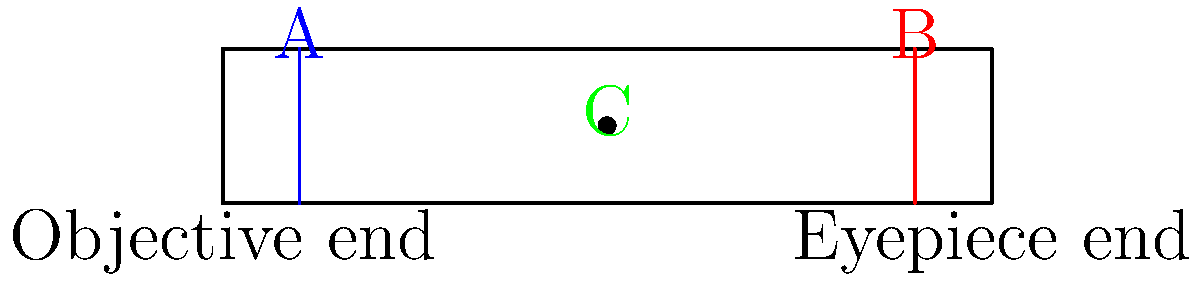In the schematic diagram of a refracting telescope above, what do the components labeled A, B, and C represent, and how do they contribute to the telescope's function in gathering data on distant celestial objects, which could be relevant to tracking the spread of infectious diseases from space-based observations? Step 1: Identify component A
A (blue line) represents the objective lens. It is the primary light-gathering element of the telescope.

Step 2: Understand the function of the objective lens
The objective lens collects and focuses light from distant objects, creating a real image inside the telescope. Its large diameter allows for better light collection, which is crucial for observing faint celestial objects.

Step 3: Identify component B
B (red line) represents the eyepiece. It is the lens closest to the observer's eye.

Step 4: Understand the function of the eyepiece
The eyepiece magnifies the real image formed by the objective lens, allowing the observer to see a larger, virtual image of the distant object.

Step 5: Identify component C
C (green dot) represents the focal point of the objective lens, where the real image is formed.

Step 6: Understand the importance of the focal point
The focal point is where the light rays converge after passing through the objective lens. The eyepiece is positioned to view this real image and magnify it.

Step 7: Relate to infectious disease research
In the context of infectious disease research, high-resolution images of Earth from space-based telescopes can help track environmental changes, urbanization patterns, or even algal blooms that might influence disease spread. The quality of these observations depends on the telescope's ability to gather and focus light effectively.
Answer: A: Objective lens (collects light), B: Eyepiece (magnifies image), C: Focal point (where real image forms) 